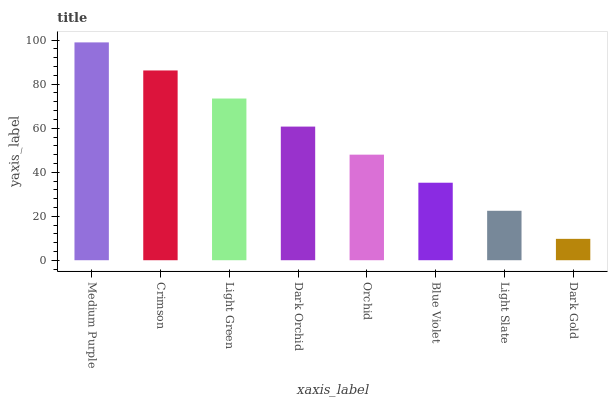Is Dark Gold the minimum?
Answer yes or no. Yes. Is Medium Purple the maximum?
Answer yes or no. Yes. Is Crimson the minimum?
Answer yes or no. No. Is Crimson the maximum?
Answer yes or no. No. Is Medium Purple greater than Crimson?
Answer yes or no. Yes. Is Crimson less than Medium Purple?
Answer yes or no. Yes. Is Crimson greater than Medium Purple?
Answer yes or no. No. Is Medium Purple less than Crimson?
Answer yes or no. No. Is Dark Orchid the high median?
Answer yes or no. Yes. Is Orchid the low median?
Answer yes or no. Yes. Is Light Slate the high median?
Answer yes or no. No. Is Blue Violet the low median?
Answer yes or no. No. 